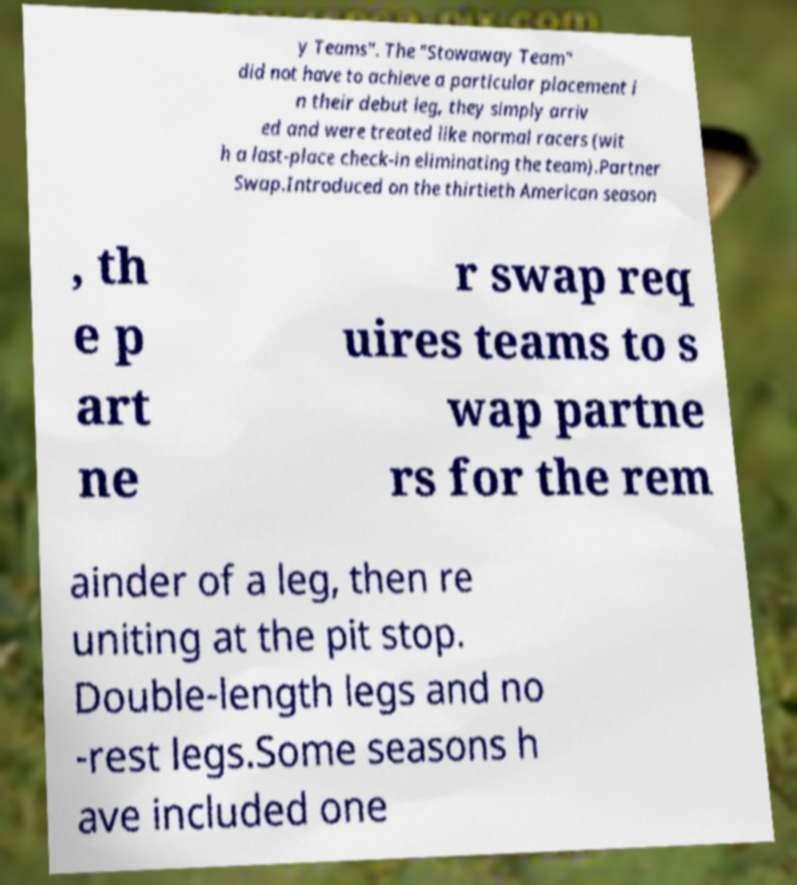Could you assist in decoding the text presented in this image and type it out clearly? y Teams". The "Stowaway Team" did not have to achieve a particular placement i n their debut leg, they simply arriv ed and were treated like normal racers (wit h a last-place check-in eliminating the team).Partner Swap.Introduced on the thirtieth American season , th e p art ne r swap req uires teams to s wap partne rs for the rem ainder of a leg, then re uniting at the pit stop. Double-length legs and no -rest legs.Some seasons h ave included one 